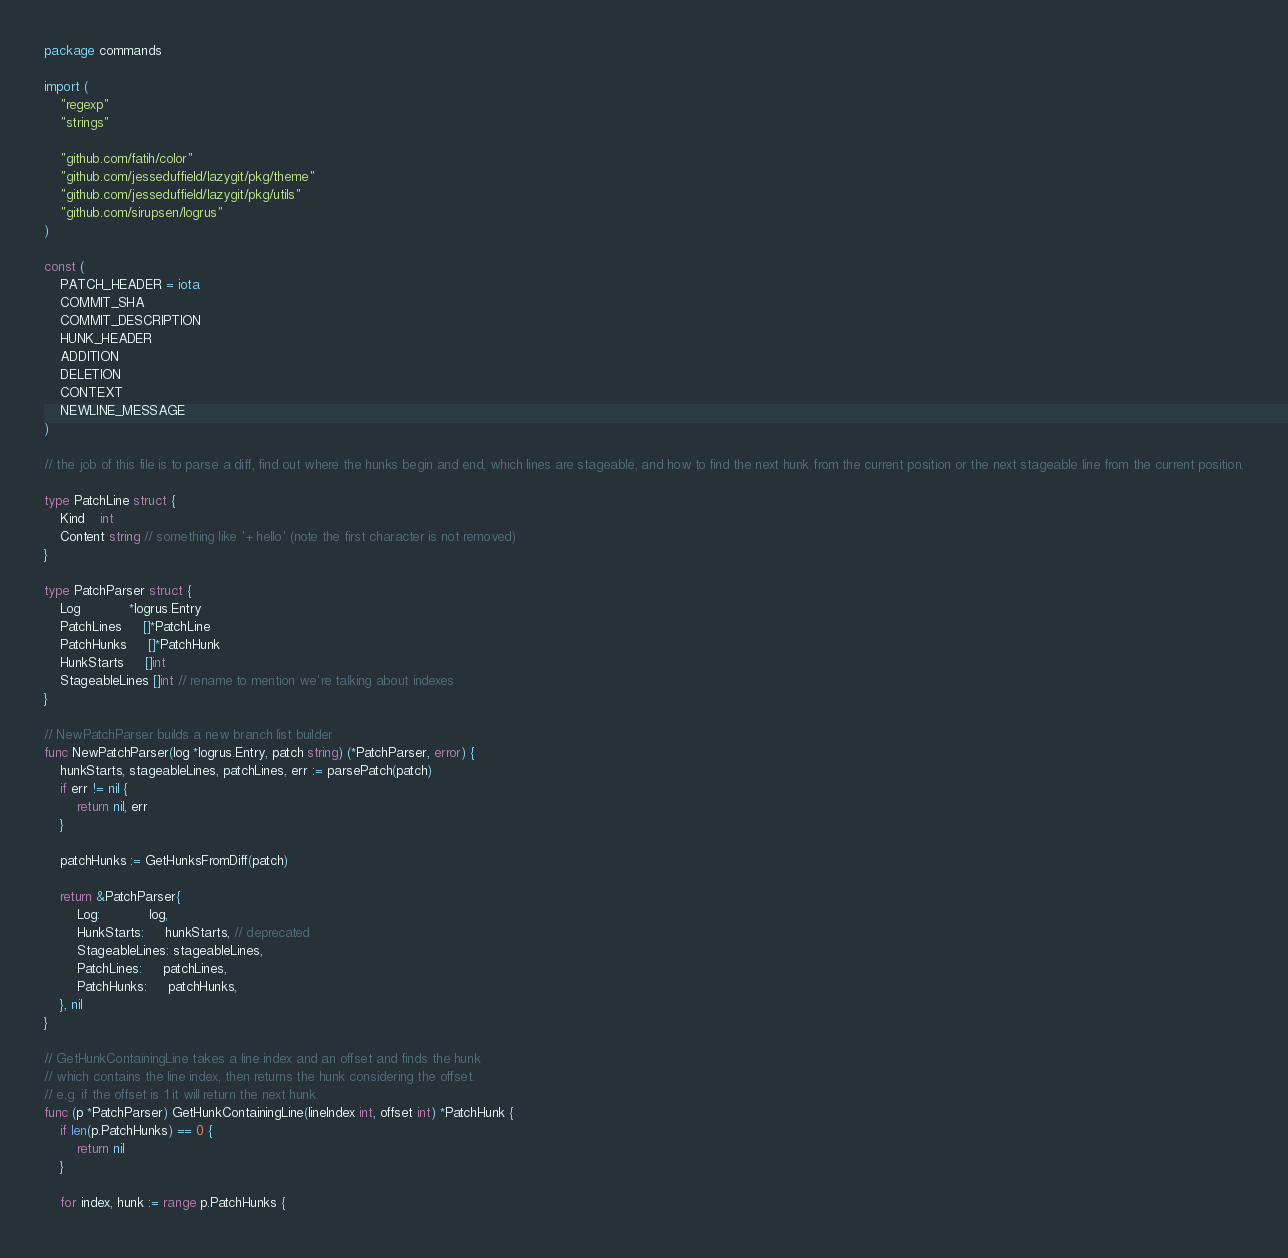Convert code to text. <code><loc_0><loc_0><loc_500><loc_500><_Go_>package commands

import (
	"regexp"
	"strings"

	"github.com/fatih/color"
	"github.com/jesseduffield/lazygit/pkg/theme"
	"github.com/jesseduffield/lazygit/pkg/utils"
	"github.com/sirupsen/logrus"
)

const (
	PATCH_HEADER = iota
	COMMIT_SHA
	COMMIT_DESCRIPTION
	HUNK_HEADER
	ADDITION
	DELETION
	CONTEXT
	NEWLINE_MESSAGE
)

// the job of this file is to parse a diff, find out where the hunks begin and end, which lines are stageable, and how to find the next hunk from the current position or the next stageable line from the current position.

type PatchLine struct {
	Kind    int
	Content string // something like '+ hello' (note the first character is not removed)
}

type PatchParser struct {
	Log            *logrus.Entry
	PatchLines     []*PatchLine
	PatchHunks     []*PatchHunk
	HunkStarts     []int
	StageableLines []int // rename to mention we're talking about indexes
}

// NewPatchParser builds a new branch list builder
func NewPatchParser(log *logrus.Entry, patch string) (*PatchParser, error) {
	hunkStarts, stageableLines, patchLines, err := parsePatch(patch)
	if err != nil {
		return nil, err
	}

	patchHunks := GetHunksFromDiff(patch)

	return &PatchParser{
		Log:            log,
		HunkStarts:     hunkStarts, // deprecated
		StageableLines: stageableLines,
		PatchLines:     patchLines,
		PatchHunks:     patchHunks,
	}, nil
}

// GetHunkContainingLine takes a line index and an offset and finds the hunk
// which contains the line index, then returns the hunk considering the offset.
// e.g. if the offset is 1 it will return the next hunk.
func (p *PatchParser) GetHunkContainingLine(lineIndex int, offset int) *PatchHunk {
	if len(p.PatchHunks) == 0 {
		return nil
	}

	for index, hunk := range p.PatchHunks {</code> 